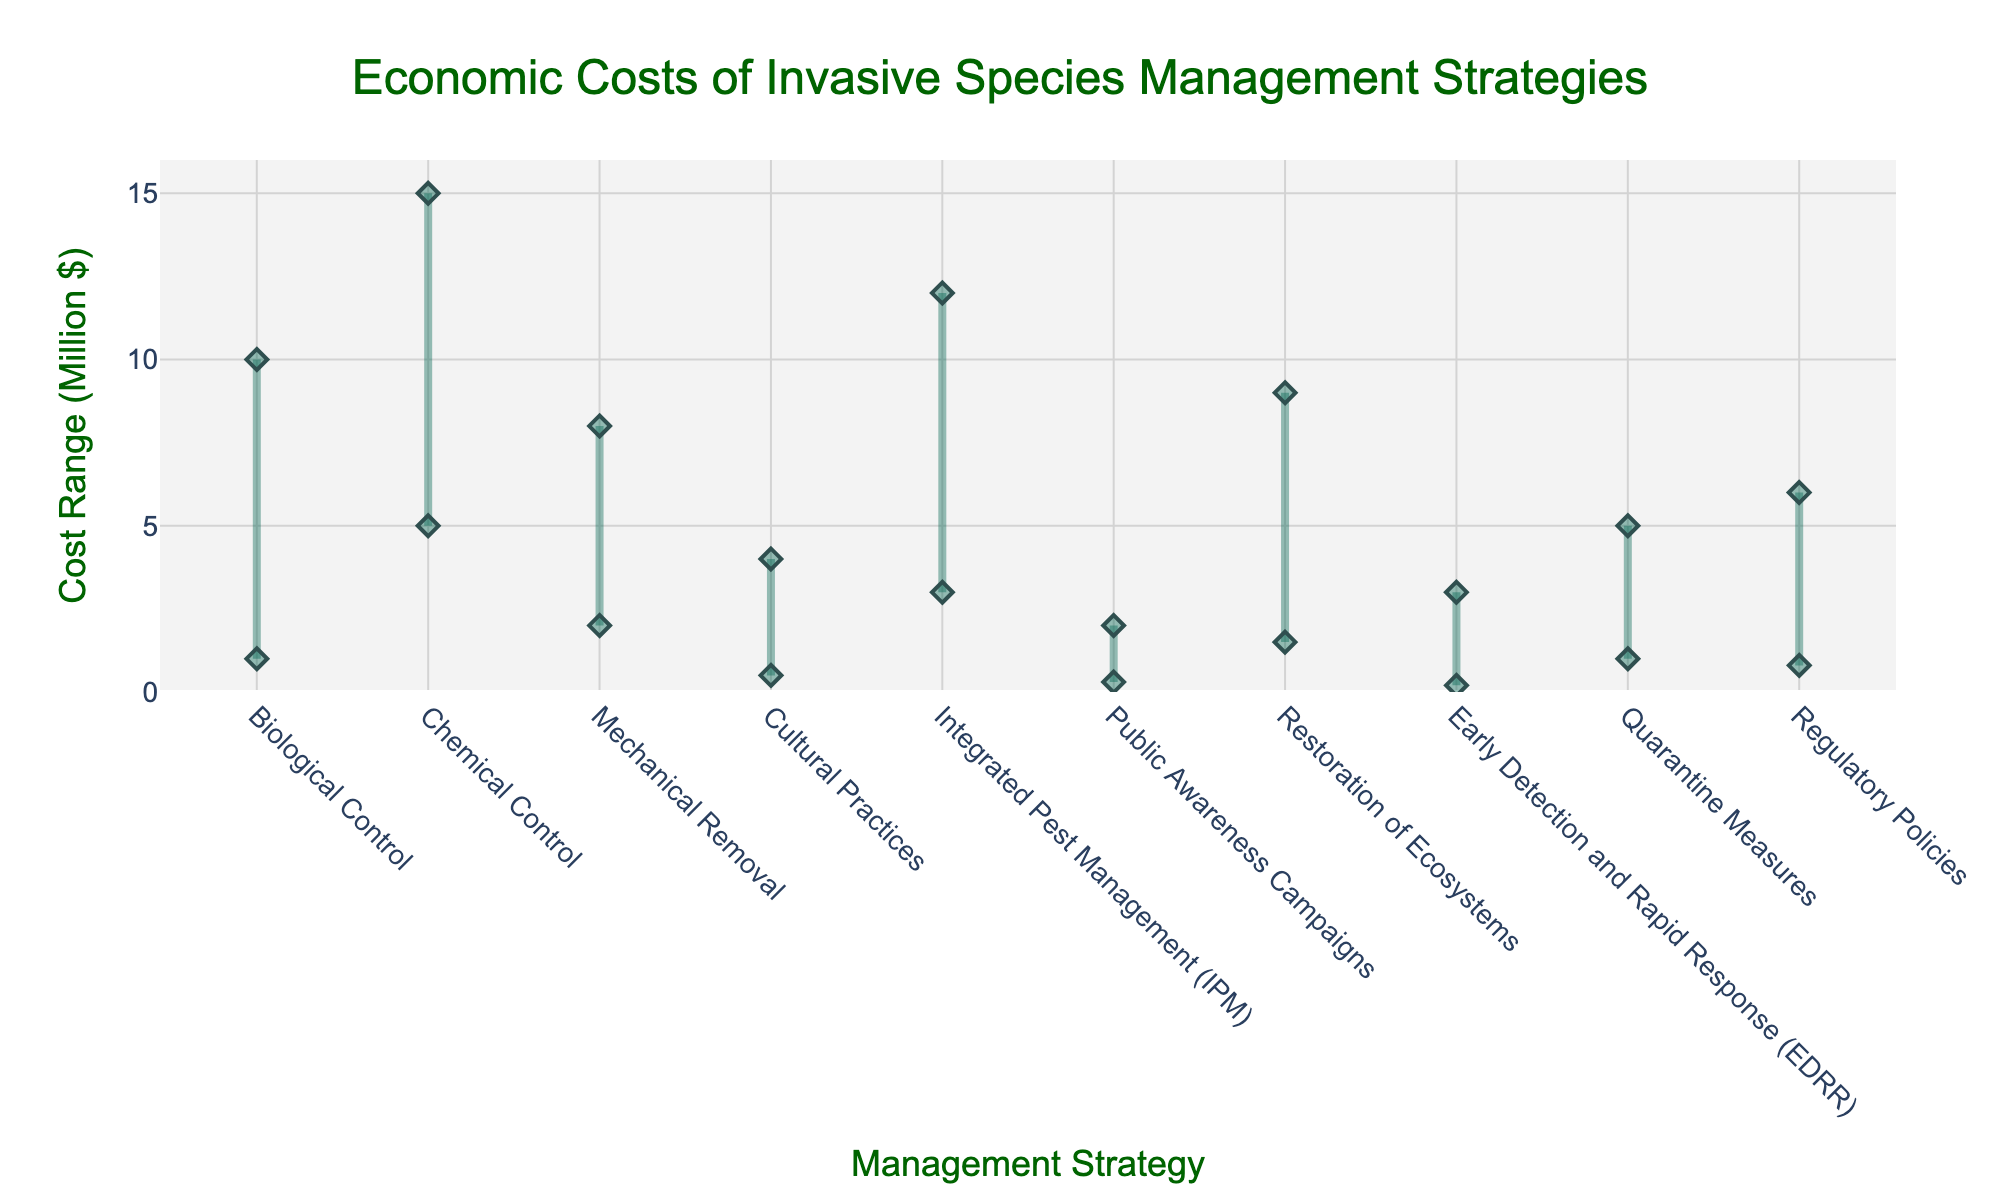What's the title of the chart? The title of the chart is displayed at the top, centered, and is in Dark Green Arial font. It reads "Economic Costs of Invasive Species Management Strategies".
Answer: Economic Costs of Invasive Species Management Strategies What is the range of costs for Biological Control? To determine the range, locate the data points for Biological Control on the y-axis; the range is from the minimum cost to the maximum cost values given for this strategy.
Answer: 1 to 10 million dollars Which management strategy has the lowest minimum cost? By examining the lowest point on the y-axis for each strategy, Early Detection and Rapid Response (EDRR) with a minimum cost of 0.2 million dollars is the lowest.
Answer: Early Detection and Rapid Response (EDRR) How many management strategies have a maximum cost greater than 10 million dollars? Identify the strategies where the upper points on the y-axis exceed 10 million dollars and count them. Here, Biological Control, Chemical Control, and Integrated Pest Management are the three strategies.
Answer: 3 What is the cost range difference between the most and least expensive management strategies? The most expensive maximum cost is for Chemical Control at 15 million dollars, and the least expensive minimum cost is for EDRR at 0.2 million dollars. Difference: 15 million - 0.2 million.
Answer: 14.8 million dollars Compare the cost ranges of Mechanical Removal and Restoration of Ecosystems. Mechanical Removal has a cost range from 2 to 8 million dollars, while Restoration of Ecosystems ranges from 1.5 to 9 million dollars.
Answer: Mechanical Removal: 2 to 8 million dollars, Restoration of Ecosystems: 1.5 to 9 million dollars What is the average maximum cost across all management strategies? Sum the maximum costs of all strategies (10+15+8+4+12+2+9+3+5+6) and divide by the number of strategies (10 strategies).
Answer: 7.4 million dollars Which strategy has the smallest range between the minimum and maximum costs? Calculate the cost range (Max - Min) for each strategy and find the smallest value. Public Awareness Campaigns has the smallest range from 0.3 to 2 million dollars, which is 1.7 million dollars.
Answer: Public Awareness Campaigns What is the total maximum cost for all management strategies combined? Sum the maximum cost values provided for each management strategy (10+15+8+4+12+2+9+3+5+6).
Answer: 74 million dollars 